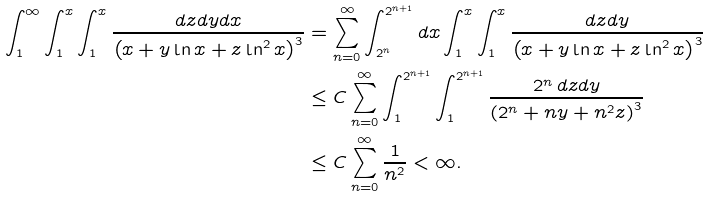<formula> <loc_0><loc_0><loc_500><loc_500>\int _ { 1 } ^ { \infty } \int _ { 1 } ^ { x } \int _ { 1 } ^ { x } \frac { d z d y d x } { \left ( x + y \ln x + z \ln ^ { 2 } x \right ) ^ { 3 } } & = \sum _ { n = 0 } ^ { \infty } \int _ { 2 ^ { n } } ^ { 2 ^ { n + 1 } } d x \int _ { 1 } ^ { x } \int _ { 1 } ^ { x } \frac { d z d y } { \left ( x + y \ln x + z \ln ^ { 2 } x \right ) ^ { 3 } } \\ & \leq C \sum _ { n = 0 } ^ { \infty } \int _ { 1 } ^ { 2 ^ { n + 1 } } \int _ { 1 } ^ { 2 ^ { n + 1 } } \frac { 2 ^ { n } \, d z d y } { \left ( 2 ^ { n } + n y + n ^ { 2 } z \right ) ^ { 3 } } \\ & \leq C \sum _ { n = 0 } ^ { \infty } \frac { 1 } { n ^ { 2 } } < \infty .</formula> 